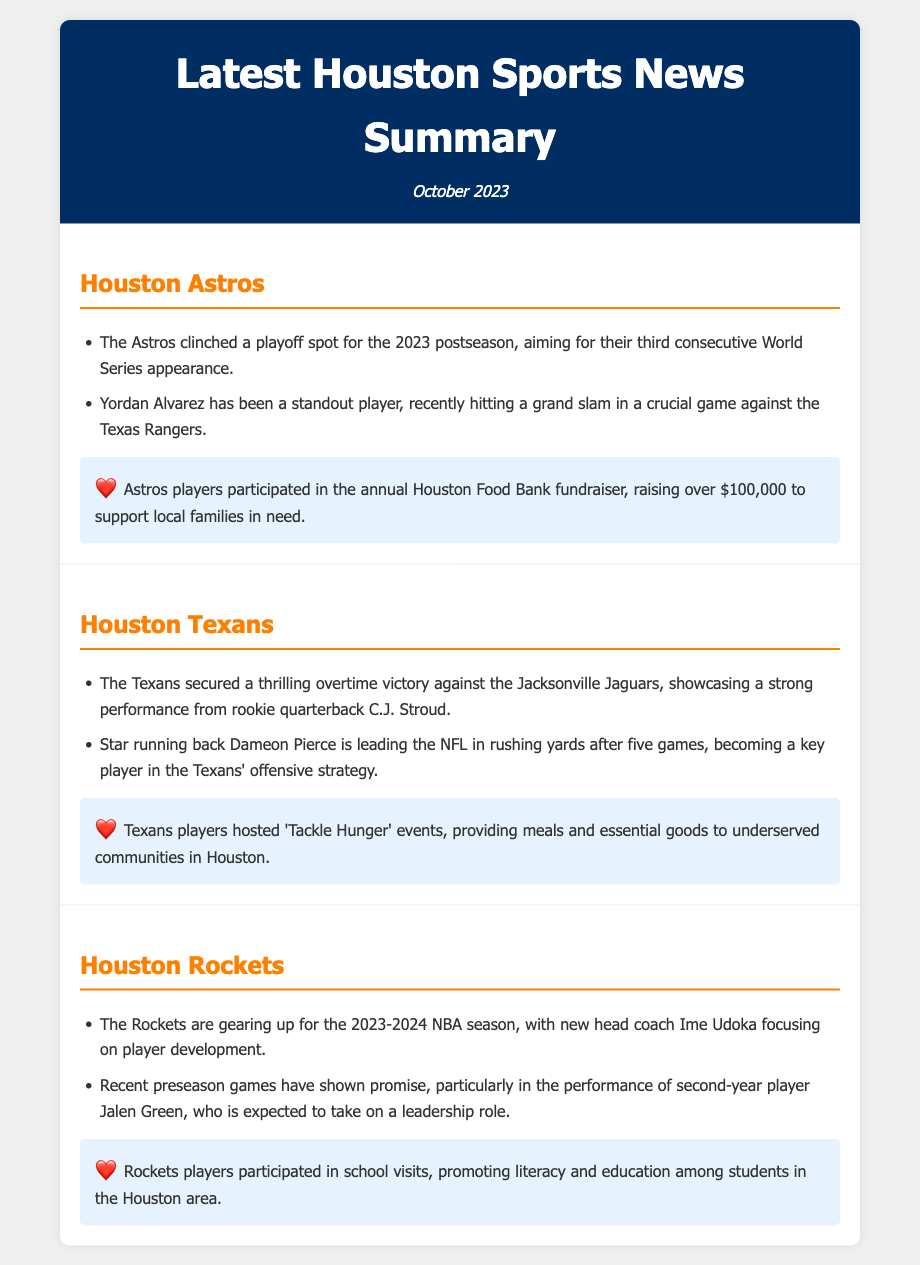What playoff position did the Astros clinch? The Astros clinched a playoff spot for the 2023 postseason.
Answer: playoff spot Who recently hit a grand slam for the Astros? Yordan Alvarez has been a standout player, recently hitting a grand slam.
Answer: Yordan Alvarez What was the outcome of the Texans' game against the Jaguars? The Texans secured a thrilling overtime victory against the Jacksonville Jaguars.
Answer: overtime victory Which player is leading the NFL in rushing yards for the Texans? Star running back Dameon Pierce is leading the NFL in rushing yards.
Answer: Dameon Pierce Who is the new head coach of the Rockets? Ime Udoka is focusing on player development as the new head coach.
Answer: Ime Udoka What community event did Astros players participate in? Astros players participated in the annual Houston Food Bank fundraiser.
Answer: Houston Food Bank fundraiser What initiative did Texans players host? Texans players hosted 'Tackle Hunger' events.
Answer: 'Tackle Hunger' events What role is Jalen Green expected to take on for the Rockets? Jalen Green is expected to take on a leadership role.
Answer: leadership role 